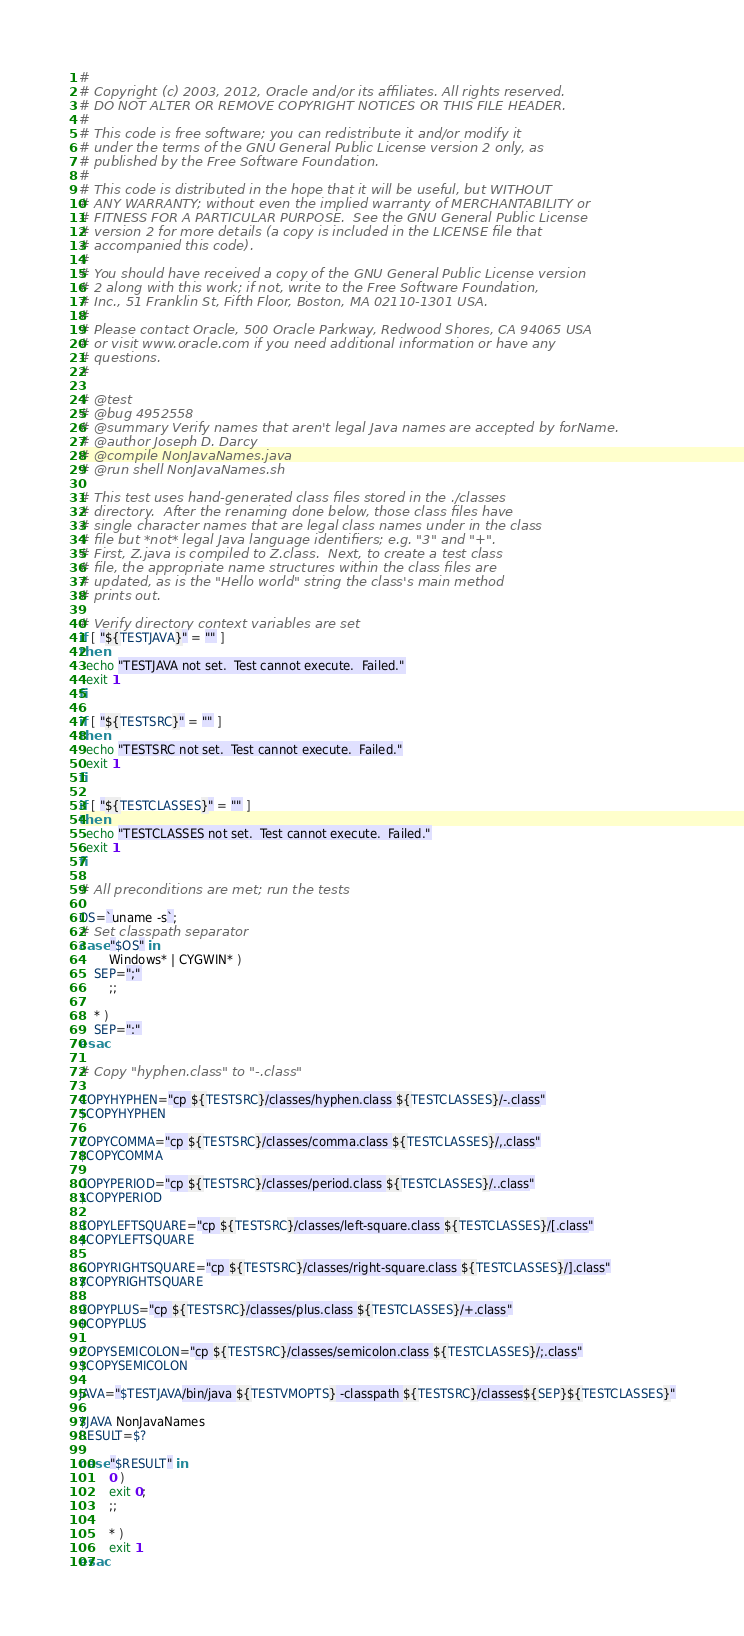<code> <loc_0><loc_0><loc_500><loc_500><_Bash_>#
# Copyright (c) 2003, 2012, Oracle and/or its affiliates. All rights reserved.
# DO NOT ALTER OR REMOVE COPYRIGHT NOTICES OR THIS FILE HEADER.
#
# This code is free software; you can redistribute it and/or modify it
# under the terms of the GNU General Public License version 2 only, as
# published by the Free Software Foundation.
#
# This code is distributed in the hope that it will be useful, but WITHOUT
# ANY WARRANTY; without even the implied warranty of MERCHANTABILITY or
# FITNESS FOR A PARTICULAR PURPOSE.  See the GNU General Public License
# version 2 for more details (a copy is included in the LICENSE file that
# accompanied this code).
#
# You should have received a copy of the GNU General Public License version
# 2 along with this work; if not, write to the Free Software Foundation,
# Inc., 51 Franklin St, Fifth Floor, Boston, MA 02110-1301 USA.
#
# Please contact Oracle, 500 Oracle Parkway, Redwood Shores, CA 94065 USA
# or visit www.oracle.com if you need additional information or have any
# questions.
#

# @test
# @bug 4952558
# @summary Verify names that aren't legal Java names are accepted by forName.
# @author Joseph D. Darcy
# @compile NonJavaNames.java
# @run shell NonJavaNames.sh

# This test uses hand-generated class files stored in the ./classes
# directory.  After the renaming done below, those class files have
# single character names that are legal class names under in the class
# file but *not* legal Java language identifiers; e.g. "3" and "+".
# First, Z.java is compiled to Z.class.  Next, to create a test class
# file, the appropriate name structures within the class files are
# updated, as is the "Hello world" string the class's main method
# prints out.

# Verify directory context variables are set
if [ "${TESTJAVA}" = "" ]
then
  echo "TESTJAVA not set.  Test cannot execute.  Failed."
  exit 1
fi

if [ "${TESTSRC}" = "" ]
then
  echo "TESTSRC not set.  Test cannot execute.  Failed."
  exit 1
fi

if [ "${TESTCLASSES}" = "" ]
then
  echo "TESTCLASSES not set.  Test cannot execute.  Failed."
  exit 1
fi

# All preconditions are met; run the tests

OS=`uname -s`;
# Set classpath separator
case "$OS" in
        Windows* | CYGWIN* )
	SEP=";"
        ;;

	* )
	SEP=":"
esac

# Copy "hyphen.class" to "-.class"

COPYHYPHEN="cp ${TESTSRC}/classes/hyphen.class ${TESTCLASSES}/-.class"
$COPYHYPHEN

COPYCOMMA="cp ${TESTSRC}/classes/comma.class ${TESTCLASSES}/,.class"
$COPYCOMMA

COPYPERIOD="cp ${TESTSRC}/classes/period.class ${TESTCLASSES}/..class"
$COPYPERIOD

COPYLEFTSQUARE="cp ${TESTSRC}/classes/left-square.class ${TESTCLASSES}/[.class"
$COPYLEFTSQUARE

COPYRIGHTSQUARE="cp ${TESTSRC}/classes/right-square.class ${TESTCLASSES}/].class"
$COPYRIGHTSQUARE

COPYPLUS="cp ${TESTSRC}/classes/plus.class ${TESTCLASSES}/+.class"
$COPYPLUS

COPYSEMICOLON="cp ${TESTSRC}/classes/semicolon.class ${TESTCLASSES}/;.class"
$COPYSEMICOLON

JAVA="$TESTJAVA/bin/java ${TESTVMOPTS} -classpath ${TESTSRC}/classes${SEP}${TESTCLASSES}"

$JAVA NonJavaNames
RESULT=$?

case "$RESULT" in
        0 )
        exit 0;
        ;;

        * )
        exit 1
esac

</code> 